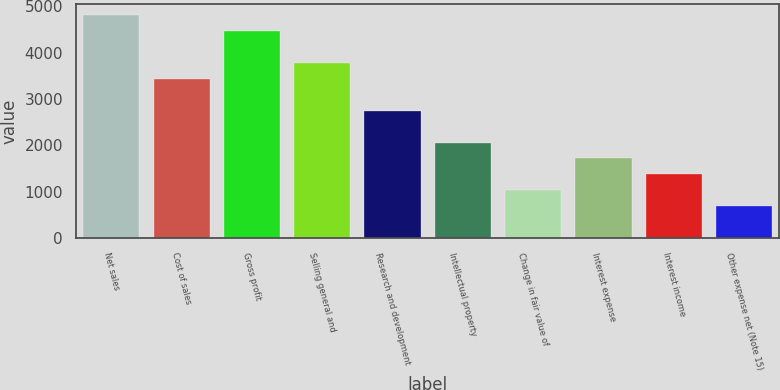Convert chart. <chart><loc_0><loc_0><loc_500><loc_500><bar_chart><fcel>Net sales<fcel>Cost of sales<fcel>Gross profit<fcel>Selling general and<fcel>Research and development<fcel>Intellectual property<fcel>Change in fair value of<fcel>Interest expense<fcel>Interest income<fcel>Other expense net (Note 15)<nl><fcel>4808.34<fcel>3435.3<fcel>4465.08<fcel>3778.56<fcel>2748.78<fcel>2062.26<fcel>1032.48<fcel>1719<fcel>1375.74<fcel>689.22<nl></chart> 